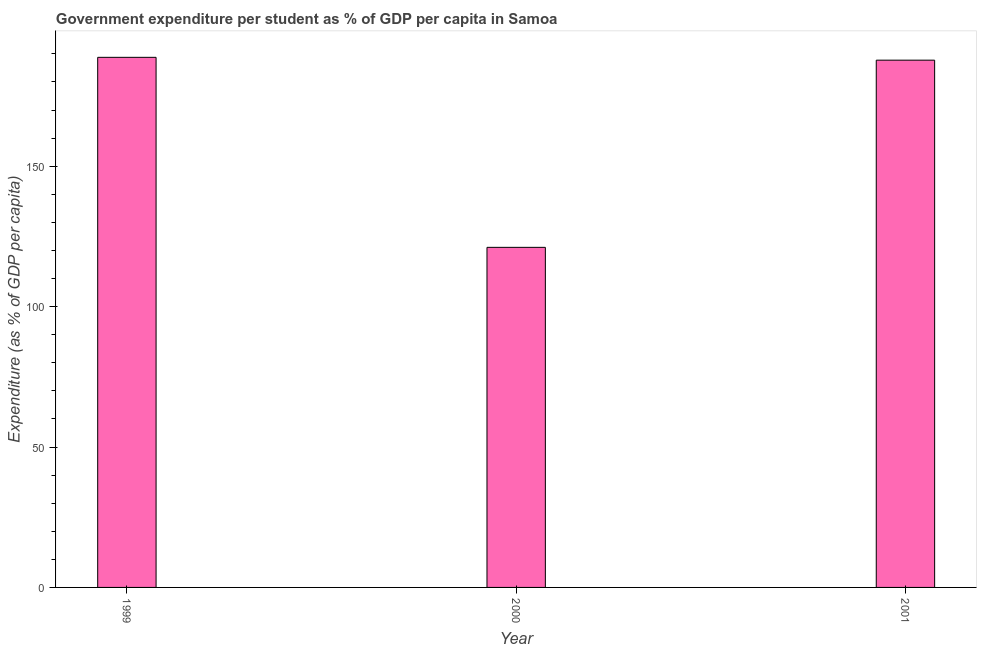What is the title of the graph?
Ensure brevity in your answer.  Government expenditure per student as % of GDP per capita in Samoa. What is the label or title of the X-axis?
Provide a succinct answer. Year. What is the label or title of the Y-axis?
Provide a short and direct response. Expenditure (as % of GDP per capita). What is the government expenditure per student in 1999?
Your answer should be compact. 188.78. Across all years, what is the maximum government expenditure per student?
Give a very brief answer. 188.78. Across all years, what is the minimum government expenditure per student?
Your answer should be compact. 121.11. What is the sum of the government expenditure per student?
Your response must be concise. 497.66. What is the difference between the government expenditure per student in 2000 and 2001?
Offer a terse response. -66.66. What is the average government expenditure per student per year?
Offer a very short reply. 165.88. What is the median government expenditure per student?
Provide a short and direct response. 187.77. Do a majority of the years between 1999 and 2001 (inclusive) have government expenditure per student greater than 20 %?
Ensure brevity in your answer.  Yes. What is the ratio of the government expenditure per student in 1999 to that in 2001?
Keep it short and to the point. 1. Is the difference between the government expenditure per student in 1999 and 2001 greater than the difference between any two years?
Keep it short and to the point. No. Is the sum of the government expenditure per student in 1999 and 2001 greater than the maximum government expenditure per student across all years?
Offer a very short reply. Yes. What is the difference between the highest and the lowest government expenditure per student?
Your answer should be very brief. 67.67. How many bars are there?
Your answer should be very brief. 3. Are all the bars in the graph horizontal?
Make the answer very short. No. How many years are there in the graph?
Offer a terse response. 3. Are the values on the major ticks of Y-axis written in scientific E-notation?
Give a very brief answer. No. What is the Expenditure (as % of GDP per capita) in 1999?
Give a very brief answer. 188.78. What is the Expenditure (as % of GDP per capita) of 2000?
Provide a short and direct response. 121.11. What is the Expenditure (as % of GDP per capita) of 2001?
Your answer should be very brief. 187.77. What is the difference between the Expenditure (as % of GDP per capita) in 1999 and 2000?
Your answer should be compact. 67.67. What is the difference between the Expenditure (as % of GDP per capita) in 1999 and 2001?
Offer a terse response. 1.01. What is the difference between the Expenditure (as % of GDP per capita) in 2000 and 2001?
Provide a short and direct response. -66.66. What is the ratio of the Expenditure (as % of GDP per capita) in 1999 to that in 2000?
Your answer should be very brief. 1.56. What is the ratio of the Expenditure (as % of GDP per capita) in 2000 to that in 2001?
Provide a short and direct response. 0.65. 